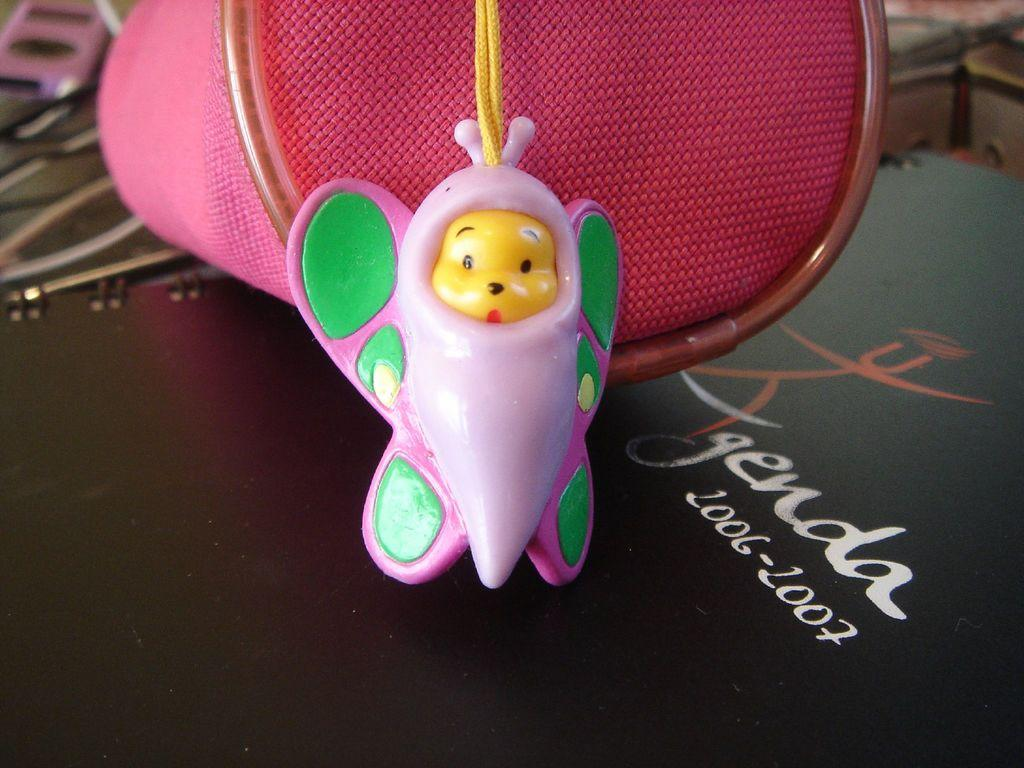What can be seen in the image that resembles a plaything? There is a toy in the image. What is located near the toy in the image? There is an object beside the toy in the image. Can you read any words or phrases in the image? There is text written on a surface in the image. How many giants are visible in the image? There are no giants present in the image. What type of system is being used to power the toy in the image? The image does not provide information about the toy's power source or any system related to it. 